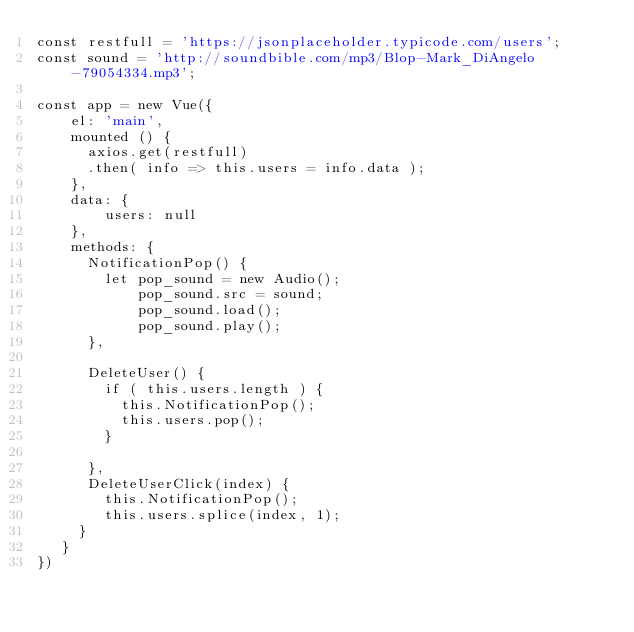Convert code to text. <code><loc_0><loc_0><loc_500><loc_500><_JavaScript_>const restfull = 'https://jsonplaceholder.typicode.com/users';
const sound = 'http://soundbible.com/mp3/Blop-Mark_DiAngelo-79054334.mp3';

const app = new Vue({
    el: 'main',
    mounted () {
      axios.get(restfull)
      .then( info => this.users = info.data );
    },
    data: {
        users: null
    },
    methods: {
      NotificationPop() {
        let pop_sound = new Audio();
            pop_sound.src = sound;
            pop_sound.load();
            pop_sound.play(); 
      },

      DeleteUser() {
        if ( this.users.length ) {
          this.NotificationPop();
          this.users.pop();    
        }
        
      },
      DeleteUserClick(index) {
        this.NotificationPop(); 
        this.users.splice(index, 1);
     }
   }
})</code> 